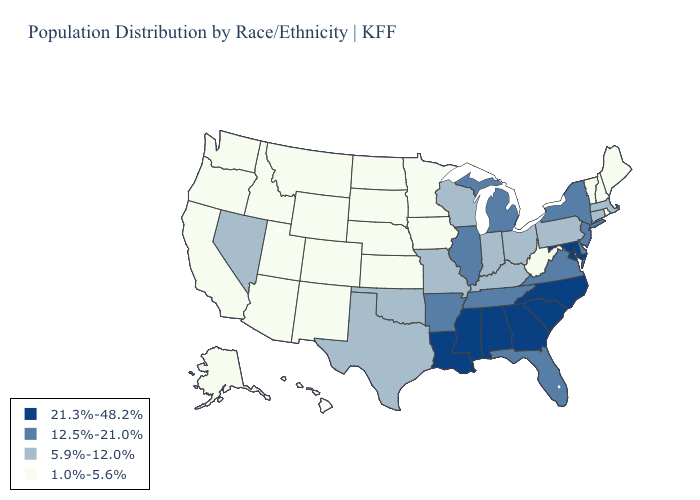Does Maryland have the highest value in the South?
Concise answer only. Yes. Among the states that border Iowa , which have the lowest value?
Write a very short answer. Minnesota, Nebraska, South Dakota. What is the value of Wisconsin?
Be succinct. 5.9%-12.0%. Which states have the lowest value in the USA?
Short answer required. Alaska, Arizona, California, Colorado, Hawaii, Idaho, Iowa, Kansas, Maine, Minnesota, Montana, Nebraska, New Hampshire, New Mexico, North Dakota, Oregon, Rhode Island, South Dakota, Utah, Vermont, Washington, West Virginia, Wyoming. Among the states that border Texas , does Arkansas have the lowest value?
Keep it brief. No. Name the states that have a value in the range 12.5%-21.0%?
Keep it brief. Arkansas, Delaware, Florida, Illinois, Michigan, New Jersey, New York, Tennessee, Virginia. What is the value of Louisiana?
Keep it brief. 21.3%-48.2%. What is the value of Arizona?
Keep it brief. 1.0%-5.6%. What is the value of Kentucky?
Answer briefly. 5.9%-12.0%. Among the states that border Louisiana , does Arkansas have the highest value?
Give a very brief answer. No. Is the legend a continuous bar?
Answer briefly. No. Does the first symbol in the legend represent the smallest category?
Quick response, please. No. Name the states that have a value in the range 5.9%-12.0%?
Be succinct. Connecticut, Indiana, Kentucky, Massachusetts, Missouri, Nevada, Ohio, Oklahoma, Pennsylvania, Texas, Wisconsin. What is the value of North Carolina?
Be succinct. 21.3%-48.2%. Which states have the lowest value in the USA?
Quick response, please. Alaska, Arizona, California, Colorado, Hawaii, Idaho, Iowa, Kansas, Maine, Minnesota, Montana, Nebraska, New Hampshire, New Mexico, North Dakota, Oregon, Rhode Island, South Dakota, Utah, Vermont, Washington, West Virginia, Wyoming. 